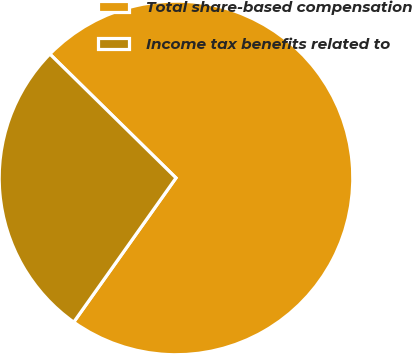Convert chart. <chart><loc_0><loc_0><loc_500><loc_500><pie_chart><fcel>Total share-based compensation<fcel>Income tax benefits related to<nl><fcel>72.46%<fcel>27.54%<nl></chart> 